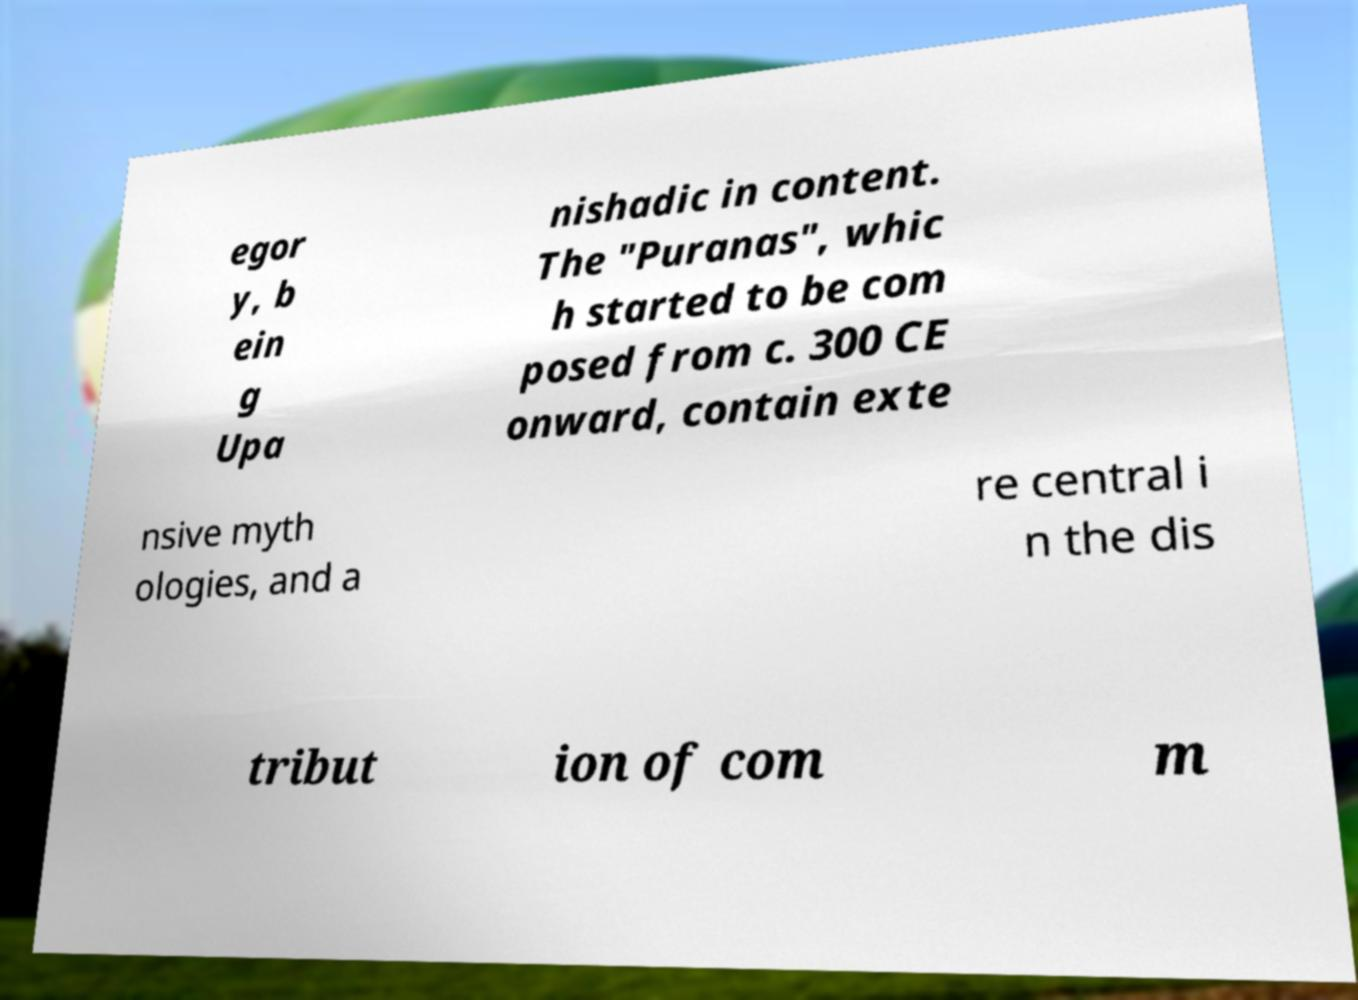Could you extract and type out the text from this image? egor y, b ein g Upa nishadic in content. The "Puranas", whic h started to be com posed from c. 300 CE onward, contain exte nsive myth ologies, and a re central i n the dis tribut ion of com m 